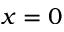<formula> <loc_0><loc_0><loc_500><loc_500>x = 0</formula> 